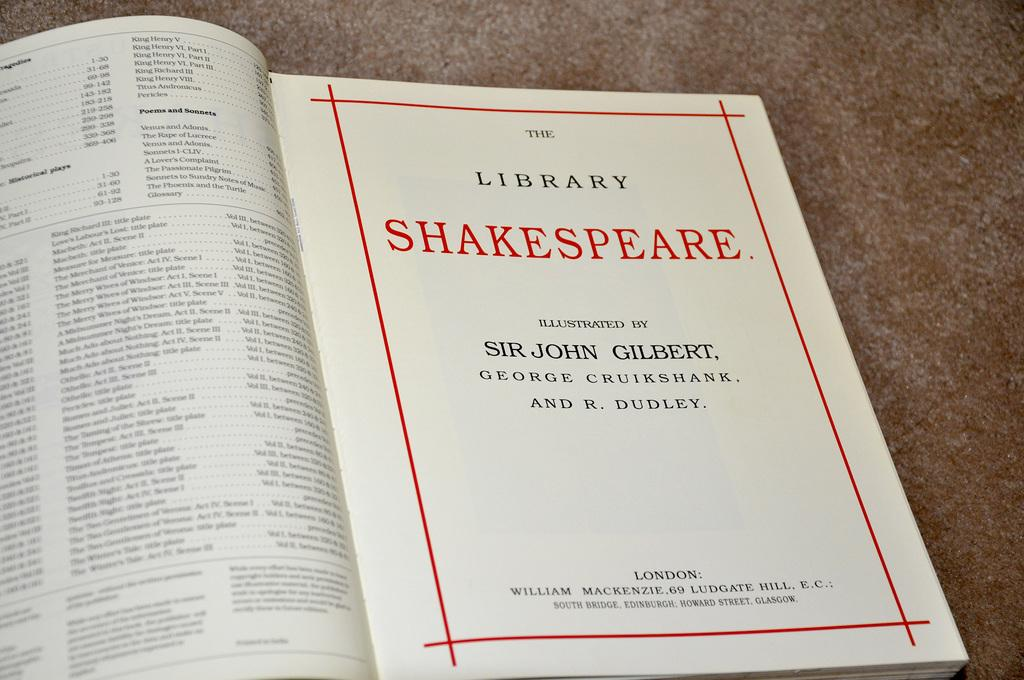<image>
Describe the image concisely. A book called The Library Shakespeare illustrated by Sir John GIlbert. 